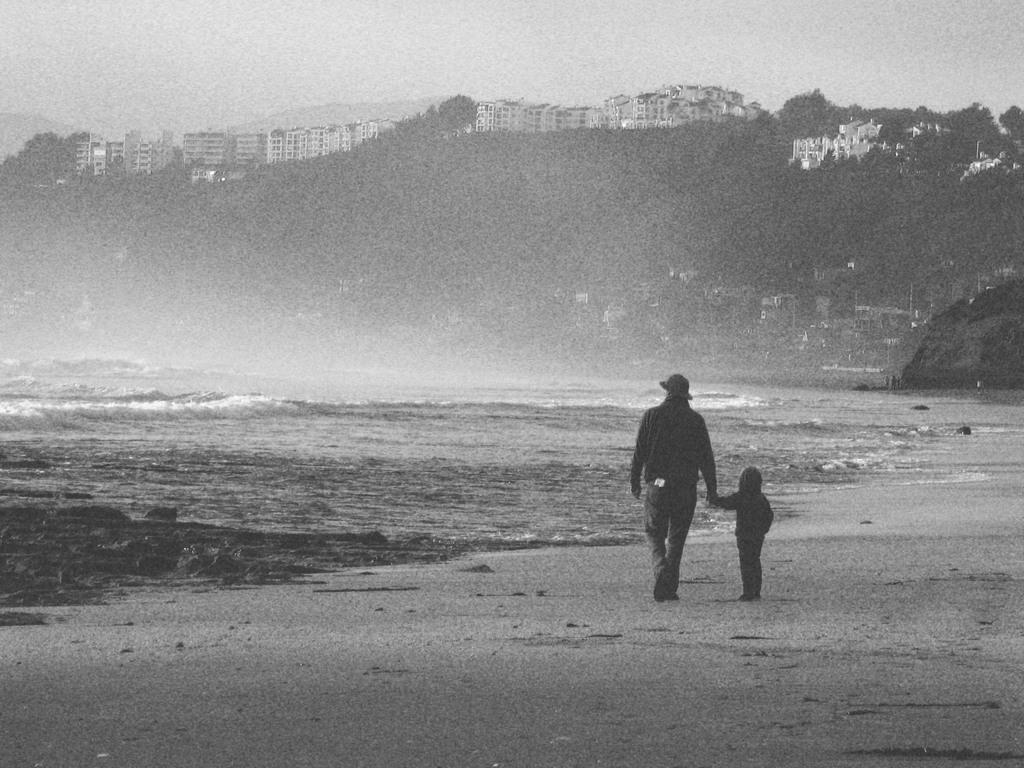Can you describe this image briefly? In this image we can see a person, a kid is walking, there are trees, buildings, also we can see the sky, and the ocean, the picture is taken in black and white mode. 